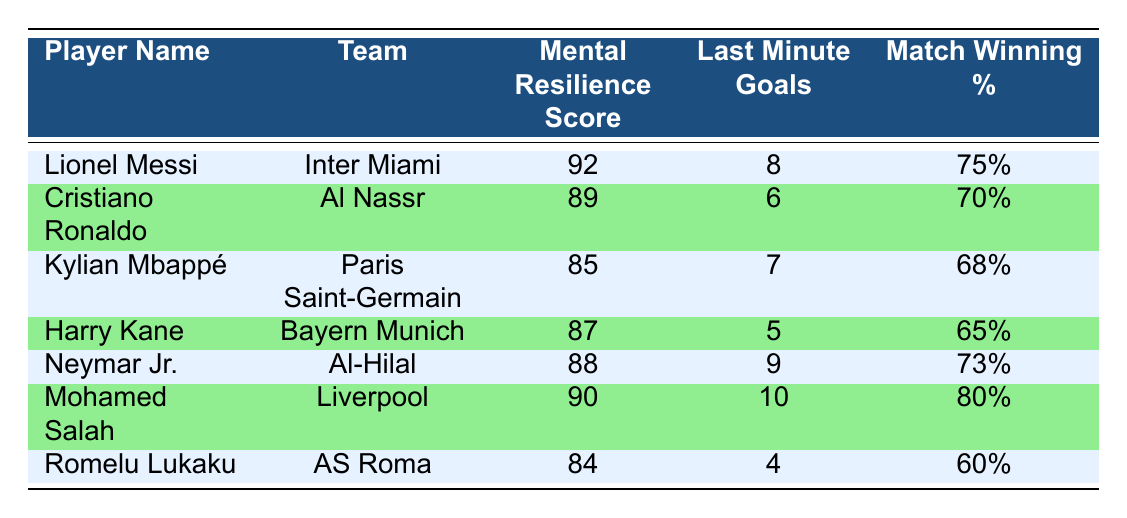What is the mental resilience score of Lionel Messi? By checking the row for Lionel Messi in the table, I see that his mental resilience score is listed as 92.
Answer: 92 How many last-minute goals did Mohamed Salah score? Looking at the row for Mohamed Salah, it shows that he scored 10 last-minute goals.
Answer: 10 Which player has the highest match-winning percentage? Comparing the match-winning percentages, Lionel Messi has 75%, Cristiano Ronaldo has 70%, Kylian Mbappé has 68%, Harry Kane has 65%, Neymar Jr. has 73%, Mohamed Salah has 80%, and Romelu Lukaku has 60%. The highest is 80% for Mohamed Salah.
Answer: Mohamed Salah Is Kylian Mbappé's mental resilience score above 85? The score for Kylian Mbappé is 85, which means it is not above 85, so the answer is false.
Answer: False What is the average number of last-minute goals scored by the players listed in the table? To find the average, I first calculate the total last-minute goals: 8 + 6 + 7 + 5 + 9 + 10 + 4 = 49. There are 7 players, therefore the average is 49/7 = 7.
Answer: 7 Are the total last-minute goals scored by Neymar Jr. and Harry Kane combined greater than the total scored by Cristiano Ronaldo and Romelu Lukaku combined? Neymar Jr. scored 9 and Harry Kane scored 5, giving a total of 9 + 5 = 14. Cristiano Ronaldo scored 6 and Romelu Lukaku scored 4, giving a total of 6 + 4 = 10. Since 14 is greater than 10, the answer is true.
Answer: True Which player has a mental resilience score lower than 85? Checking the scores, Romelu Lukaku has a score of 84, which is lower than 85.
Answer: Romelu Lukaku What is the combined match-winning percentage of Lionel Messi and Neymar Jr.? Adding their percentages: Messi has 75% and Neymar Jr. has 73%. Therefore, the combined percentage is 75 + 73 = 148%.
Answer: 148% 